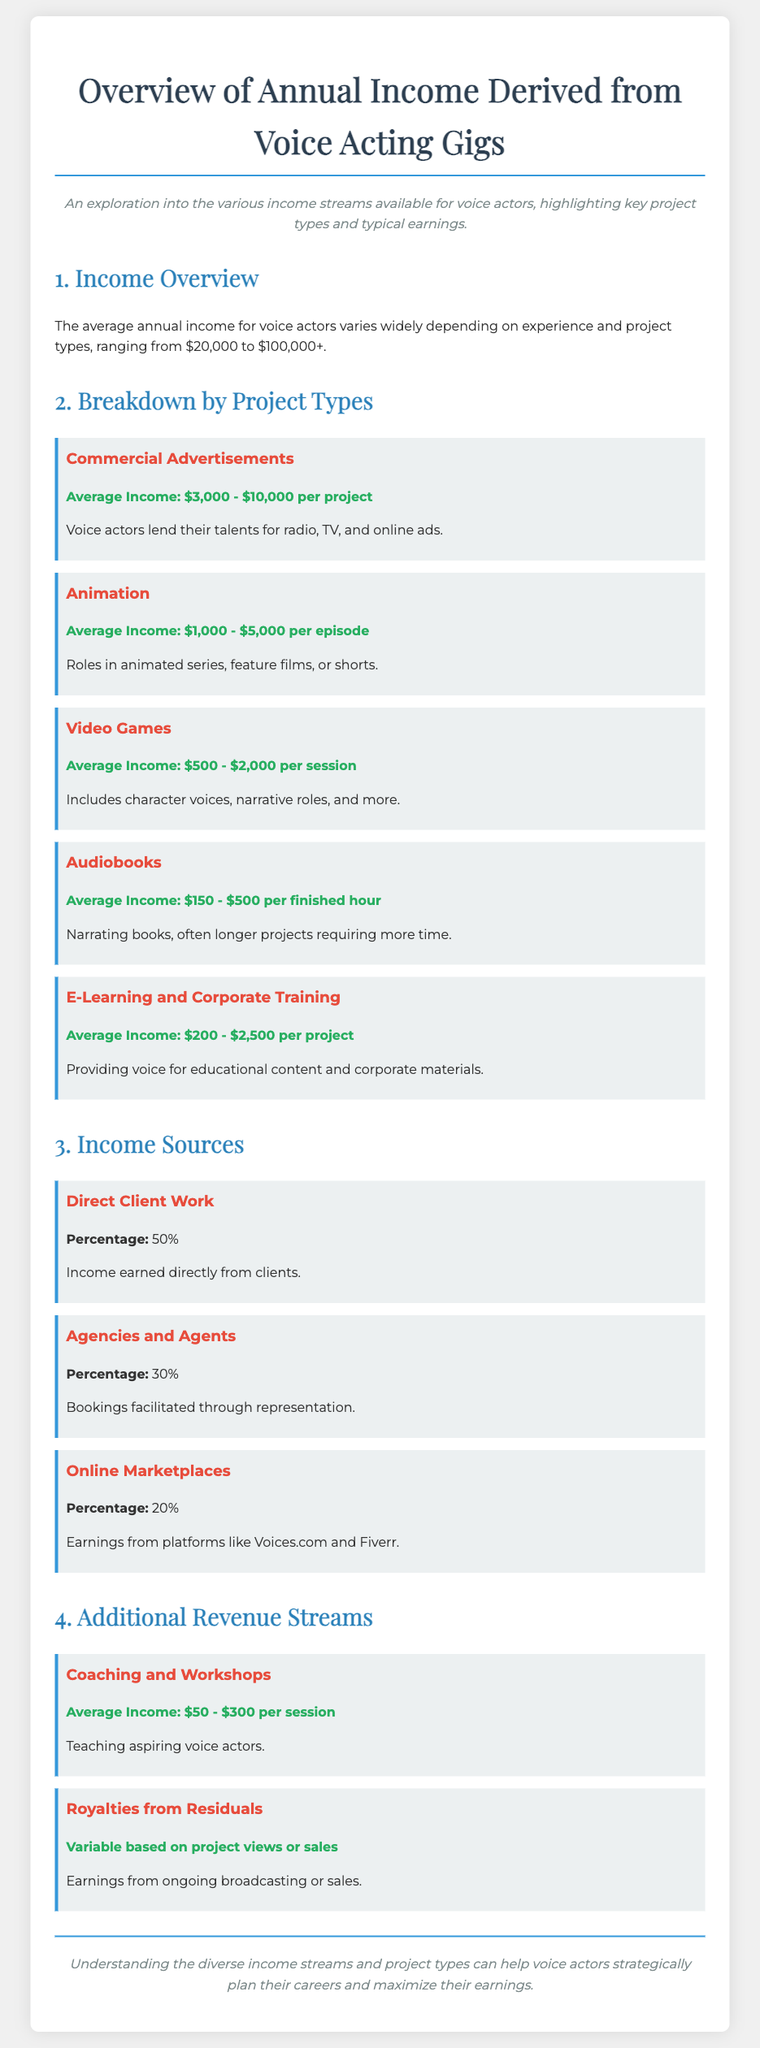What is the average annual income for voice actors? The document states that the average annual income for voice actors varies widely, with a range of $20,000 to $100,000+.
Answer: $20,000 to $100,000+ What is the average income for a commercial advertisement project? According to the breakdown by project types, the average income for a commercial advertisement ranges from $3,000 to $10,000 per project.
Answer: $3,000 - $10,000 What percentage of income is derived from direct client work? The document specifies that the percentage of income from direct client work is 50%.
Answer: 50% What is the average income for audiobooks? The average income for audiobooks is mentioned as $150 to $500 per finished hour.
Answer: $150 - $500 Which project type has the highest average income range? The highest average income range is found in commercial advertisements, which has an average income of $3,000 to $10,000 per project.
Answer: Commercial Advertisements Which income source accounts for 30% of earnings? The document indicates that income from agencies and agents accounts for 30% of earnings.
Answer: Agencies and Agents How much can be earned from coaching and workshops per session? The average income that can be earned from coaching and workshops ranges from $50 to $300 per session.
Answer: $50 - $300 What type of projects does the video games category include? The video games category includes character voices, narrative roles, and more.
Answer: Character voices, narrative roles, and more What is the typical earnings structure for online marketplaces? The document states that the earnings from online marketplaces, like Voices.com and Fiverr, account for 20% of income.
Answer: 20% 